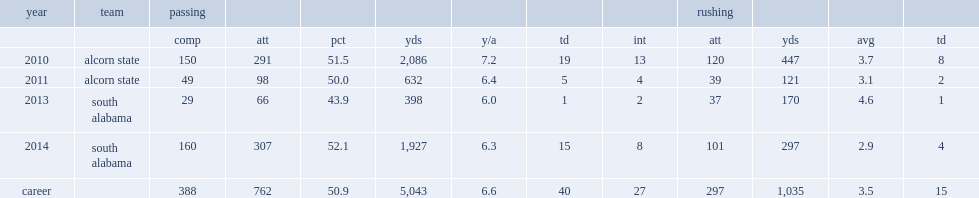In 2011, how many yards did brandon bridge rush for? 121.0. How many passing yards did brandon bridge get in 2013? 398.0. 